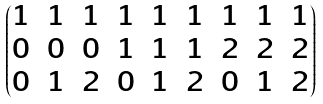<formula> <loc_0><loc_0><loc_500><loc_500>\begin{pmatrix} 1 & 1 & 1 & 1 & 1 & 1 & 1 & 1 & 1 \\ 0 & 0 & 0 & 1 & 1 & 1 & 2 & 2 & 2 \\ 0 & 1 & 2 & 0 & 1 & 2 & 0 & 1 & 2 \end{pmatrix}</formula> 